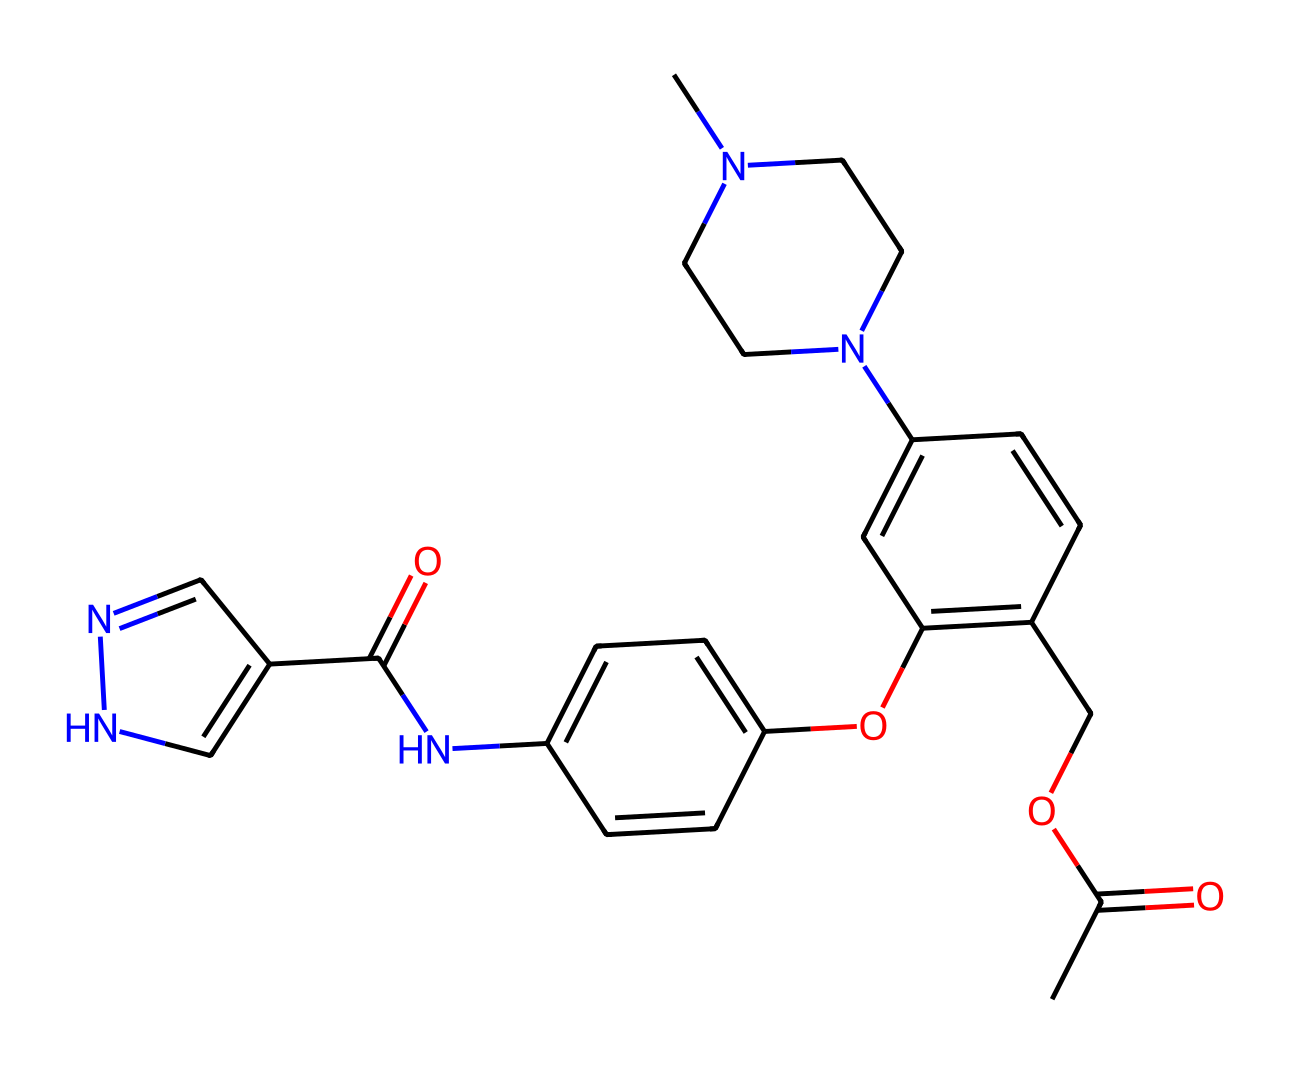What is the functional group present in this chemical? The structure presents an ester functional group, identified by the presence of a carbonyl group (C=O) adjacent to an ether (–O–) bond. This is characteristic of esters.
Answer: ester How many nitrogen atoms are in this chemical? By scanning the structure, we can count three nitrogen atoms, marked within the cyclic parts and the side chains of the molecule.
Answer: 3 What type of bond primarily connects the carbonyl carbon to the oxygen in the ester group? The bond that connects the carbonyl carbon to the oxygen is a single bond, as it is part of the ester functional group's structure.
Answer: single bond How many rings are in this chemical structure? The chemical contains three distinct ring structures, identified by the cyclic configurations present within the overall molecular framework.
Answer: 3 What role does the ester group play in the properties of this chemical? The ester group is responsible for enhancing lipophilicity, which can influence the solubility and permeability of the compound through biological membranes.
Answer: lipophilicity What is the molecular weight of this compound? By summing the atomic weights of all atoms present in the SMILES representation, the calculated molecular weight of the compound is approximately 420.5 grams per mole.
Answer: 420.5 What is the primary use of this chemical in a sci-fi context? In the context of advanced neural implants, this ester is designed to enhance memory retention and cognitive function by acting on synaptic pathways.
Answer: memory enhancement 